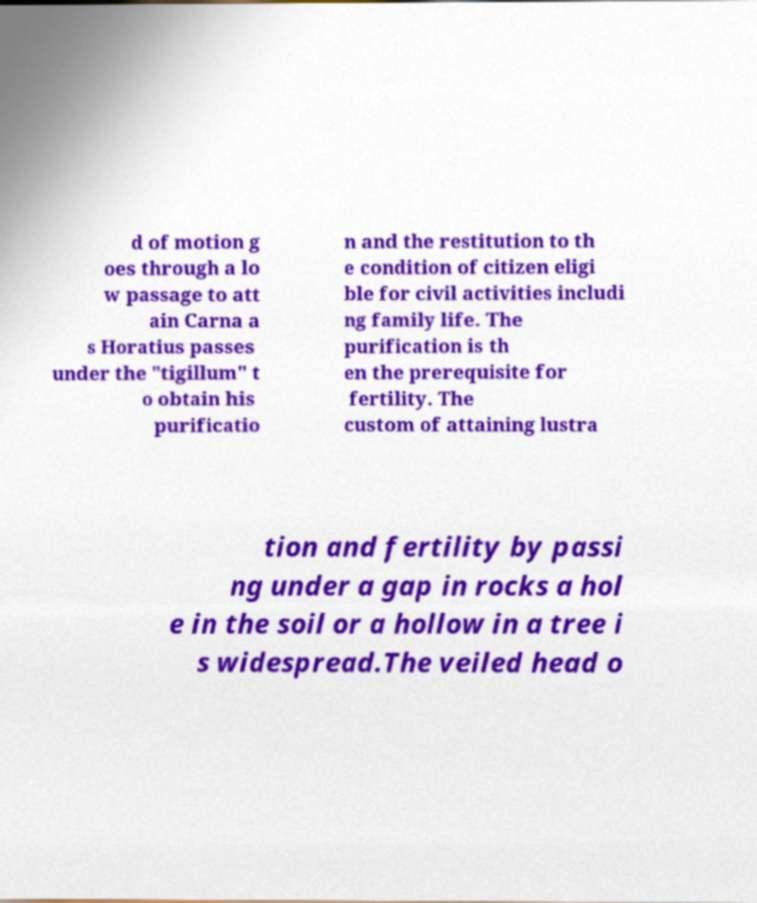There's text embedded in this image that I need extracted. Can you transcribe it verbatim? d of motion g oes through a lo w passage to att ain Carna a s Horatius passes under the "tigillum" t o obtain his purificatio n and the restitution to th e condition of citizen eligi ble for civil activities includi ng family life. The purification is th en the prerequisite for fertility. The custom of attaining lustra tion and fertility by passi ng under a gap in rocks a hol e in the soil or a hollow in a tree i s widespread.The veiled head o 